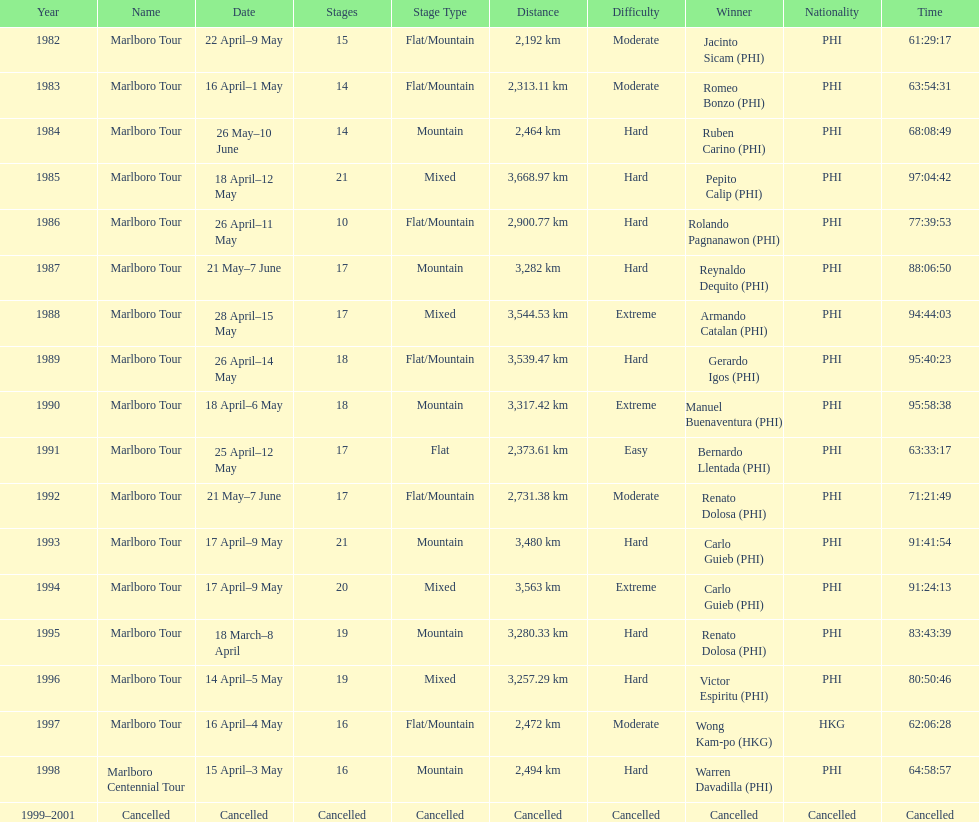How many marlboro tours did carlo guieb win? 2. 